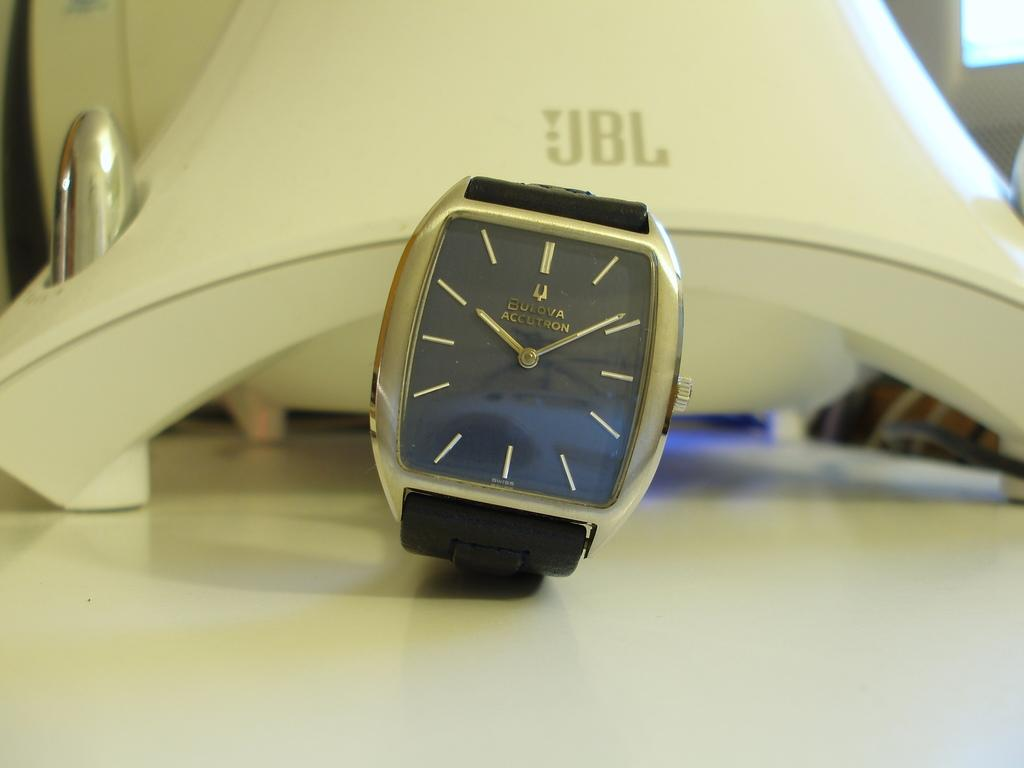<image>
Write a terse but informative summary of the picture. A new modern watch sitting in front of a JBL speaker 